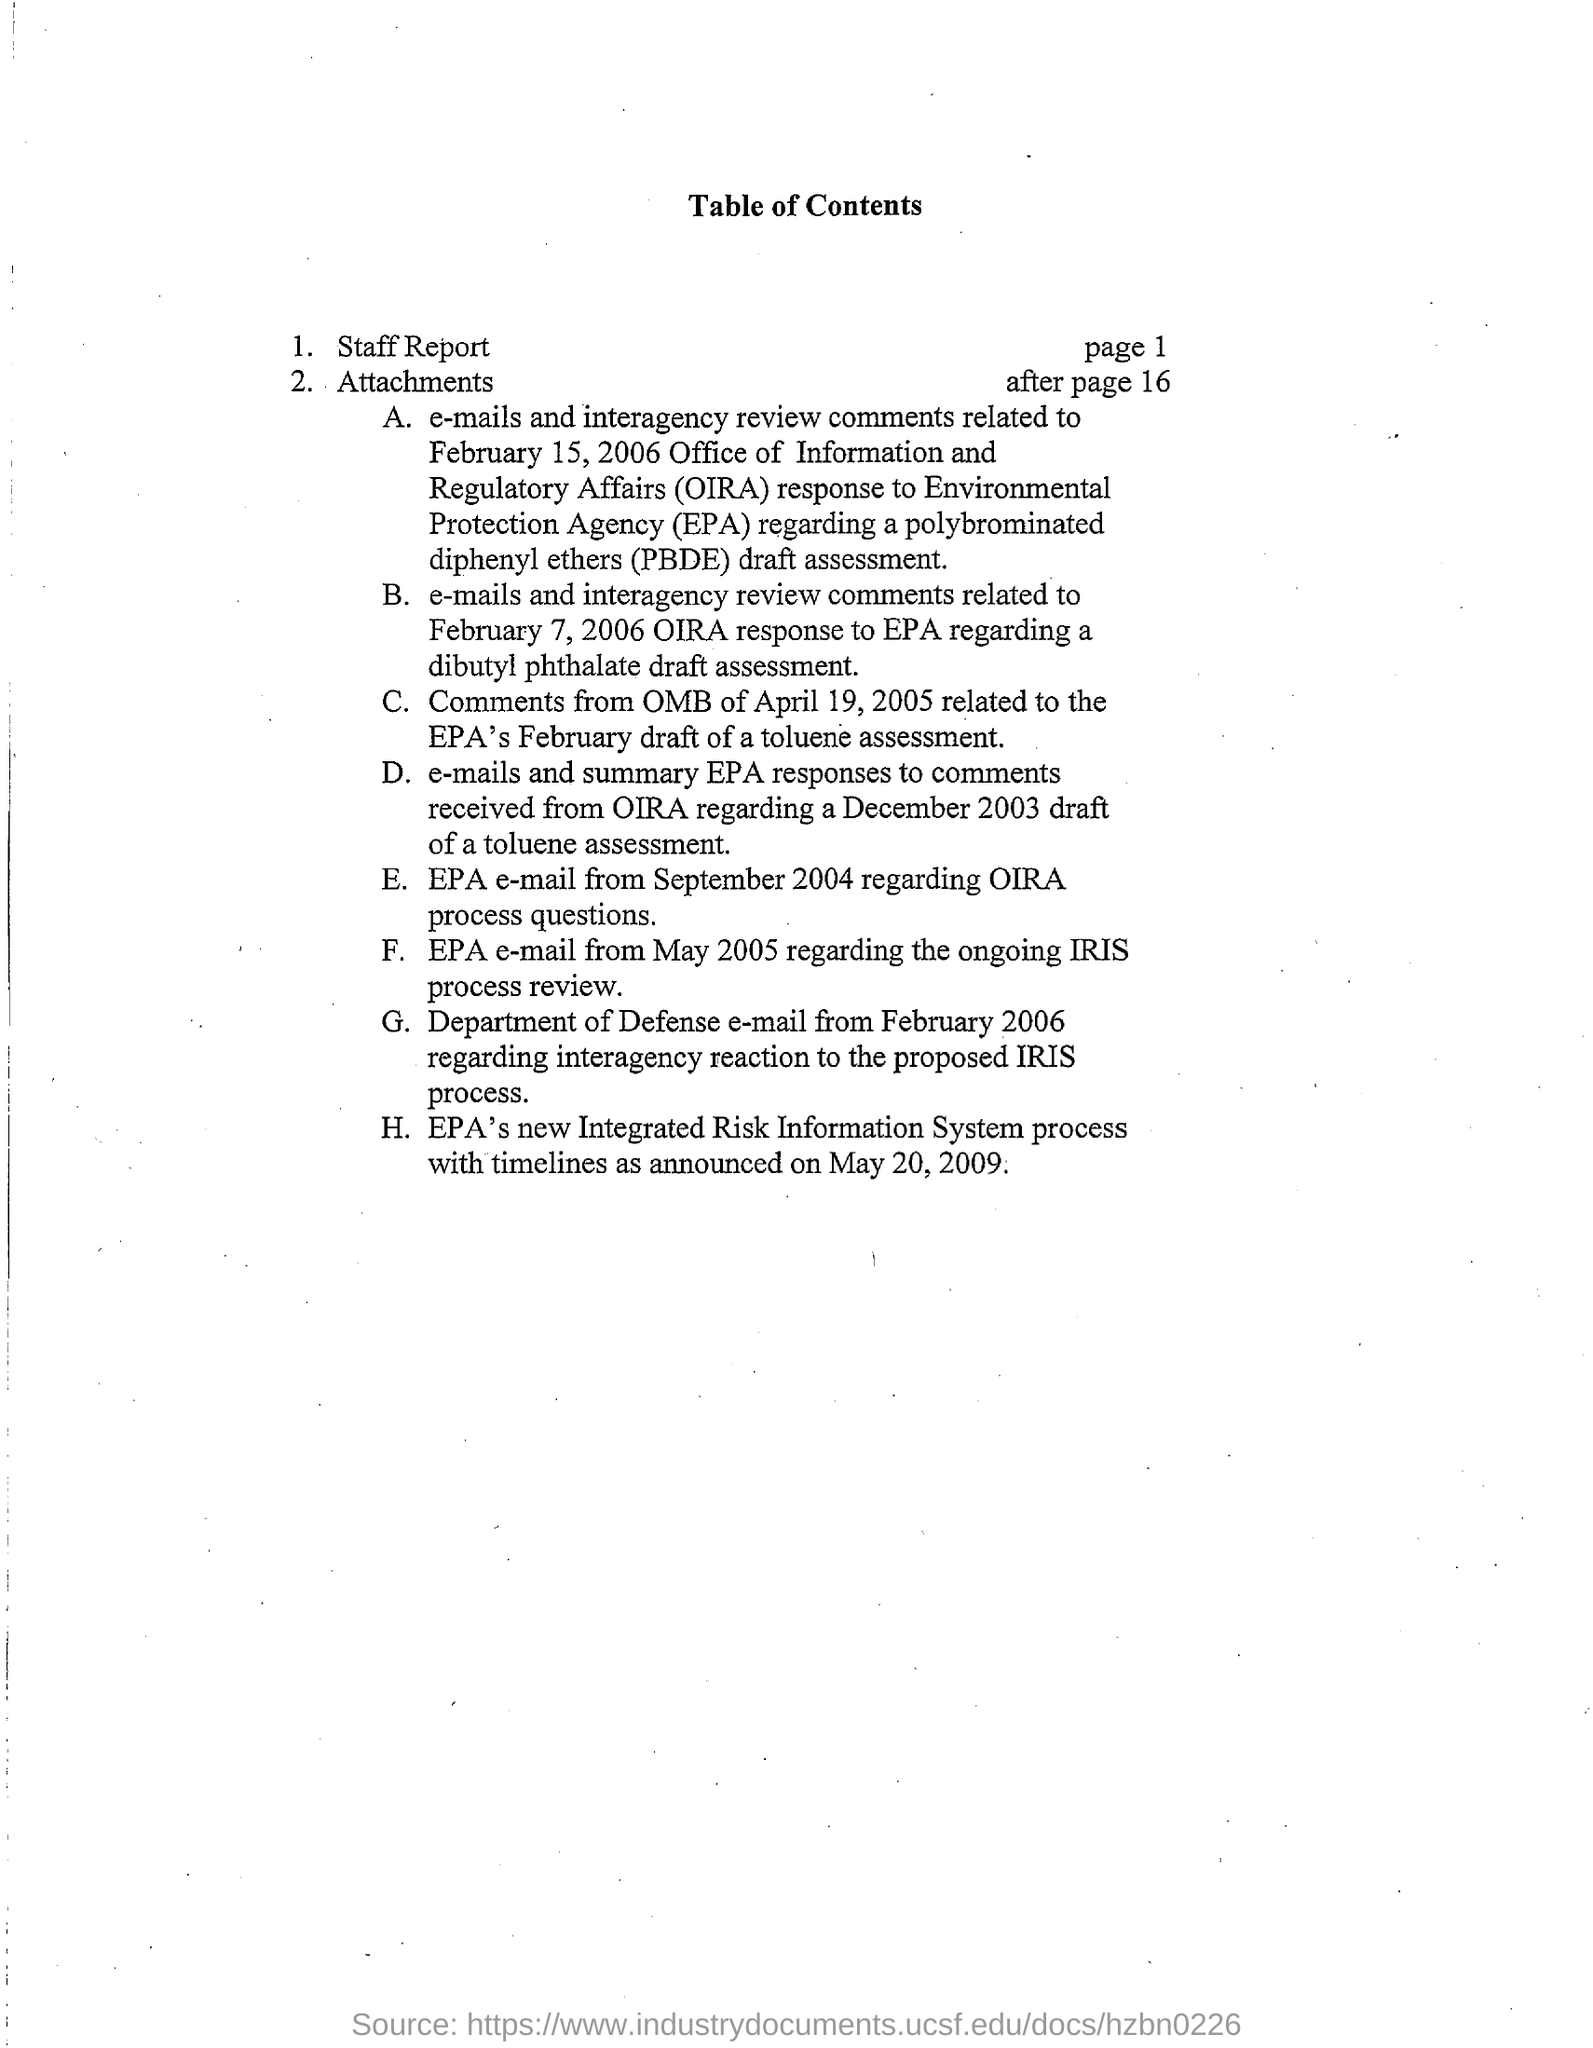Specify some key components in this picture. The Office of Information and Regulatory Affairs (OIRA) is an office within the Office of Management and Budget (OMB) of the executive branch of the United States federal government. OIRA provides oversight of the regulatory policies and procedures of the federal government and is responsible for reviewing and approving or rejecting government regulations before they are implemented. The Environmental Protection Agency (EPA) is a federal agency responsible for protecting the environment and human health. PBDE stands for polybrominated diphenyl ethers, a type of flame retardant commonly used in plastics and textiles. These chemicals are known to be toxic and have been banned in some countries, but they remain in use in others. 